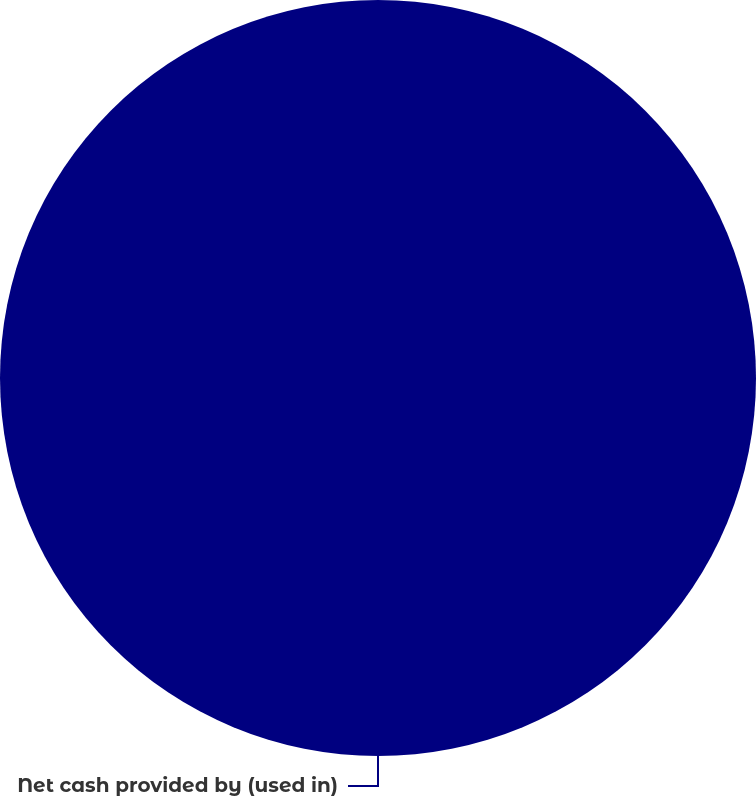Convert chart. <chart><loc_0><loc_0><loc_500><loc_500><pie_chart><fcel>Net cash provided by (used in)<nl><fcel>100.0%<nl></chart> 